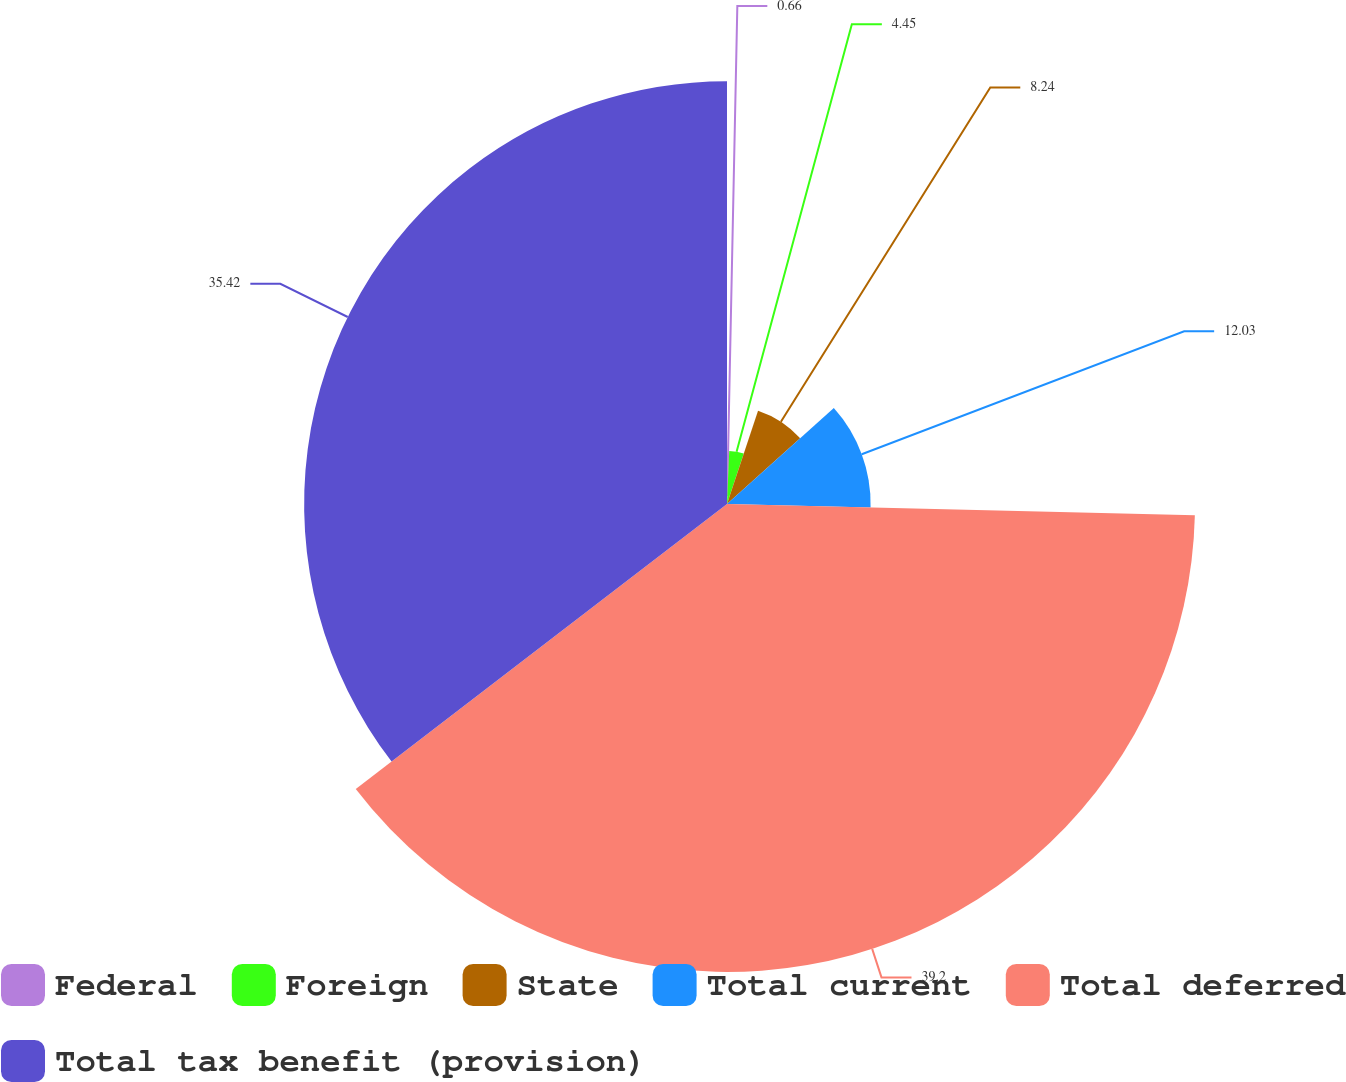<chart> <loc_0><loc_0><loc_500><loc_500><pie_chart><fcel>Federal<fcel>Foreign<fcel>State<fcel>Total current<fcel>Total deferred<fcel>Total tax benefit (provision)<nl><fcel>0.66%<fcel>4.45%<fcel>8.24%<fcel>12.03%<fcel>39.2%<fcel>35.42%<nl></chart> 